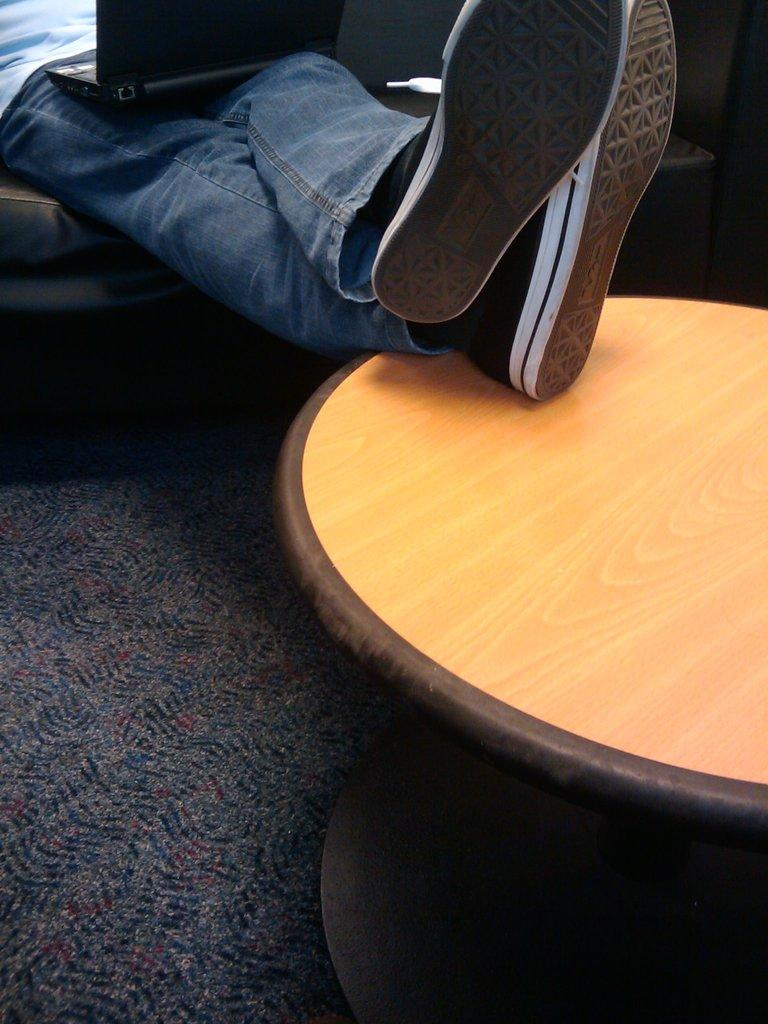What electronic device is visible in the image? There is a laptop in the image. Where is the laptop placed? The laptop is on a person's leg. What is supporting the person's legs in the image? The person's legs are on a table. Can you see a river flowing near the person in the image? No, there is no river visible in the image. 